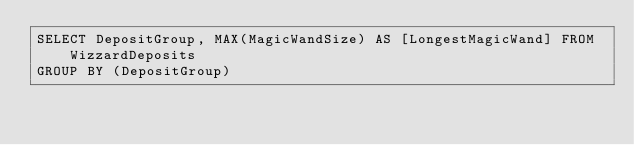Convert code to text. <code><loc_0><loc_0><loc_500><loc_500><_SQL_>SELECT DepositGroup, MAX(MagicWandSize) AS [LongestMagicWand] FROM WizzardDeposits
GROUP BY (DepositGroup)</code> 